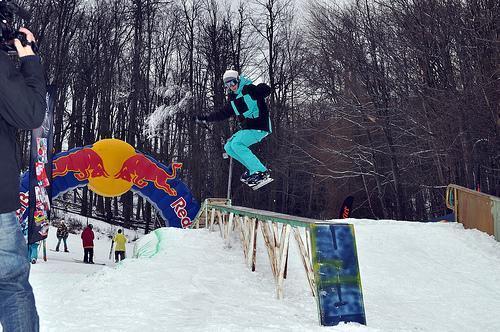How many rails are visible?
Give a very brief answer. 1. 